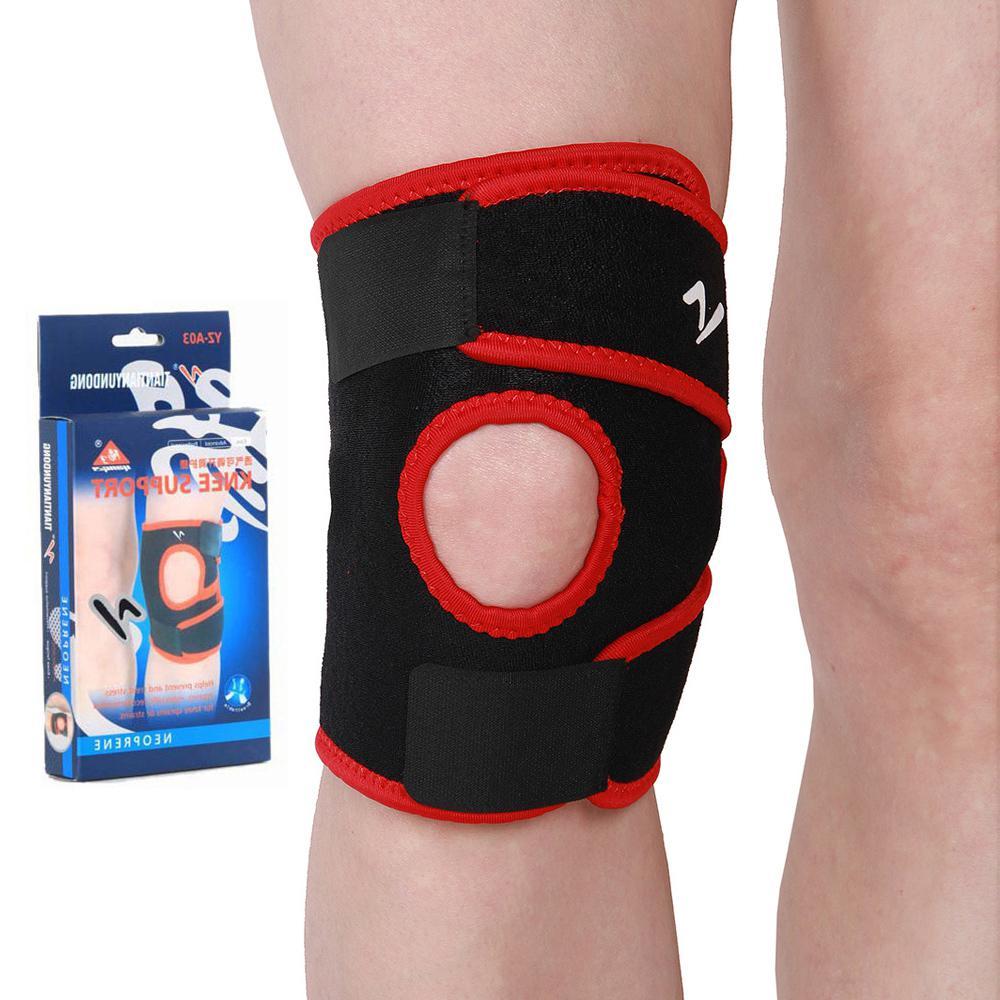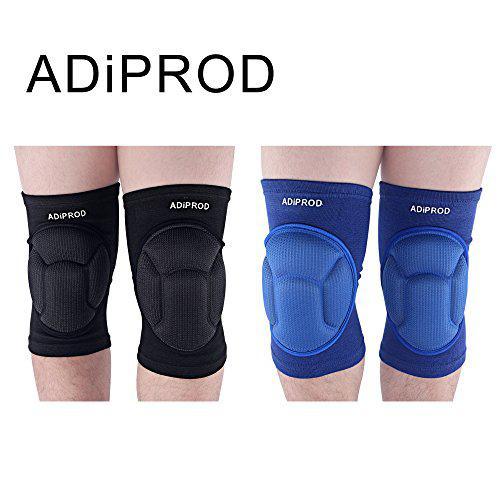The first image is the image on the left, the second image is the image on the right. Examine the images to the left and right. Is the description "In at least one image there are four kneepads." accurate? Answer yes or no. Yes. The first image is the image on the left, the second image is the image on the right. Considering the images on both sides, is "All knee pads are black, and each image includes a pair of legs with at least one leg wearing a knee pad." valid? Answer yes or no. No. 